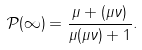Convert formula to latex. <formula><loc_0><loc_0><loc_500><loc_500>\mathcal { P } ( \infty ) = \frac { \mu + ( \mu \nu ) } { \mu ( \mu \nu ) + 1 } .</formula> 